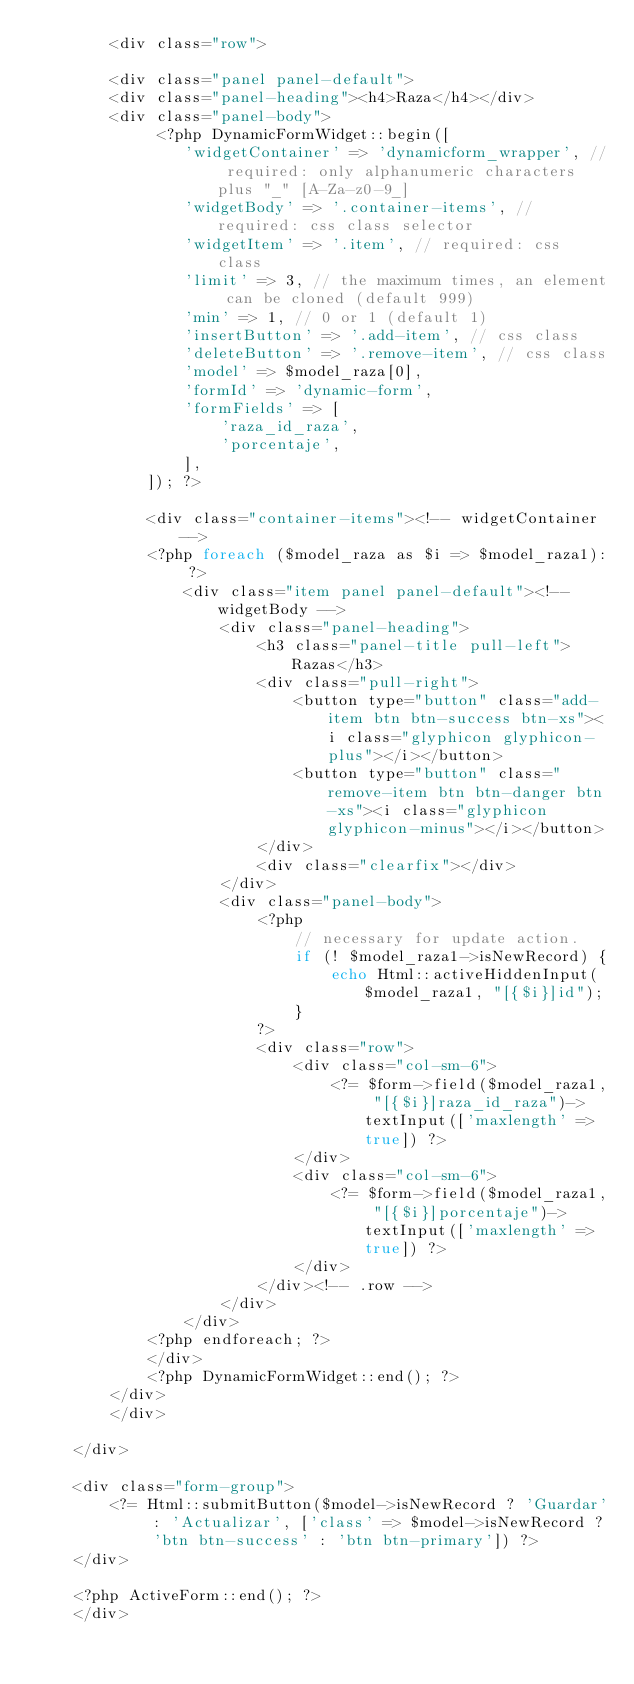<code> <loc_0><loc_0><loc_500><loc_500><_PHP_>        <div class="row">

        <div class="panel panel-default">
        <div class="panel-heading"><h4>Raza</h4></div>
        <div class="panel-body">
             <?php DynamicFormWidget::begin([
                'widgetContainer' => 'dynamicform_wrapper', // required: only alphanumeric characters plus "_" [A-Za-z0-9_]
                'widgetBody' => '.container-items', // required: css class selector
                'widgetItem' => '.item', // required: css class
                'limit' => 3, // the maximum times, an element can be cloned (default 999)
                'min' => 1, // 0 or 1 (default 1)
                'insertButton' => '.add-item', // css class
                'deleteButton' => '.remove-item', // css class
                'model' => $model_raza[0],
                'formId' => 'dynamic-form',
                'formFields' => [
                    'raza_id_raza',
                    'porcentaje',
                ],
            ]); ?>

            <div class="container-items"><!-- widgetContainer -->
            <?php foreach ($model_raza as $i => $model_raza1): ?>
                <div class="item panel panel-default"><!-- widgetBody -->
                    <div class="panel-heading">
                        <h3 class="panel-title pull-left">Razas</h3>
                        <div class="pull-right">
                            <button type="button" class="add-item btn btn-success btn-xs"><i class="glyphicon glyphicon-plus"></i></button>
                            <button type="button" class="remove-item btn btn-danger btn-xs"><i class="glyphicon glyphicon-minus"></i></button>
                        </div>
                        <div class="clearfix"></div>
                    </div>
                    <div class="panel-body">
                        <?php
                            // necessary for update action.
                            if (! $model_raza1->isNewRecord) {
                                echo Html::activeHiddenInput($model_raza1, "[{$i}]id");
                            }
                        ?>
                        <div class="row">
                            <div class="col-sm-6">
                                <?= $form->field($model_raza1, "[{$i}]raza_id_raza")->textInput(['maxlength' => true]) ?>
                            </div>
                            <div class="col-sm-6">
                                <?= $form->field($model_raza1, "[{$i}]porcentaje")->textInput(['maxlength' => true]) ?>
                            </div>
                        </div><!-- .row -->
                    </div>
                </div>
            <?php endforeach; ?>
            </div>
            <?php DynamicFormWidget::end(); ?>
        </div>
        </div>

    </div>

    <div class="form-group">
        <?= Html::submitButton($model->isNewRecord ? 'Guardar' : 'Actualizar', ['class' => $model->isNewRecord ? 'btn btn-success' : 'btn btn-primary']) ?>
    </div>

    <?php ActiveForm::end(); ?>
    </div></code> 